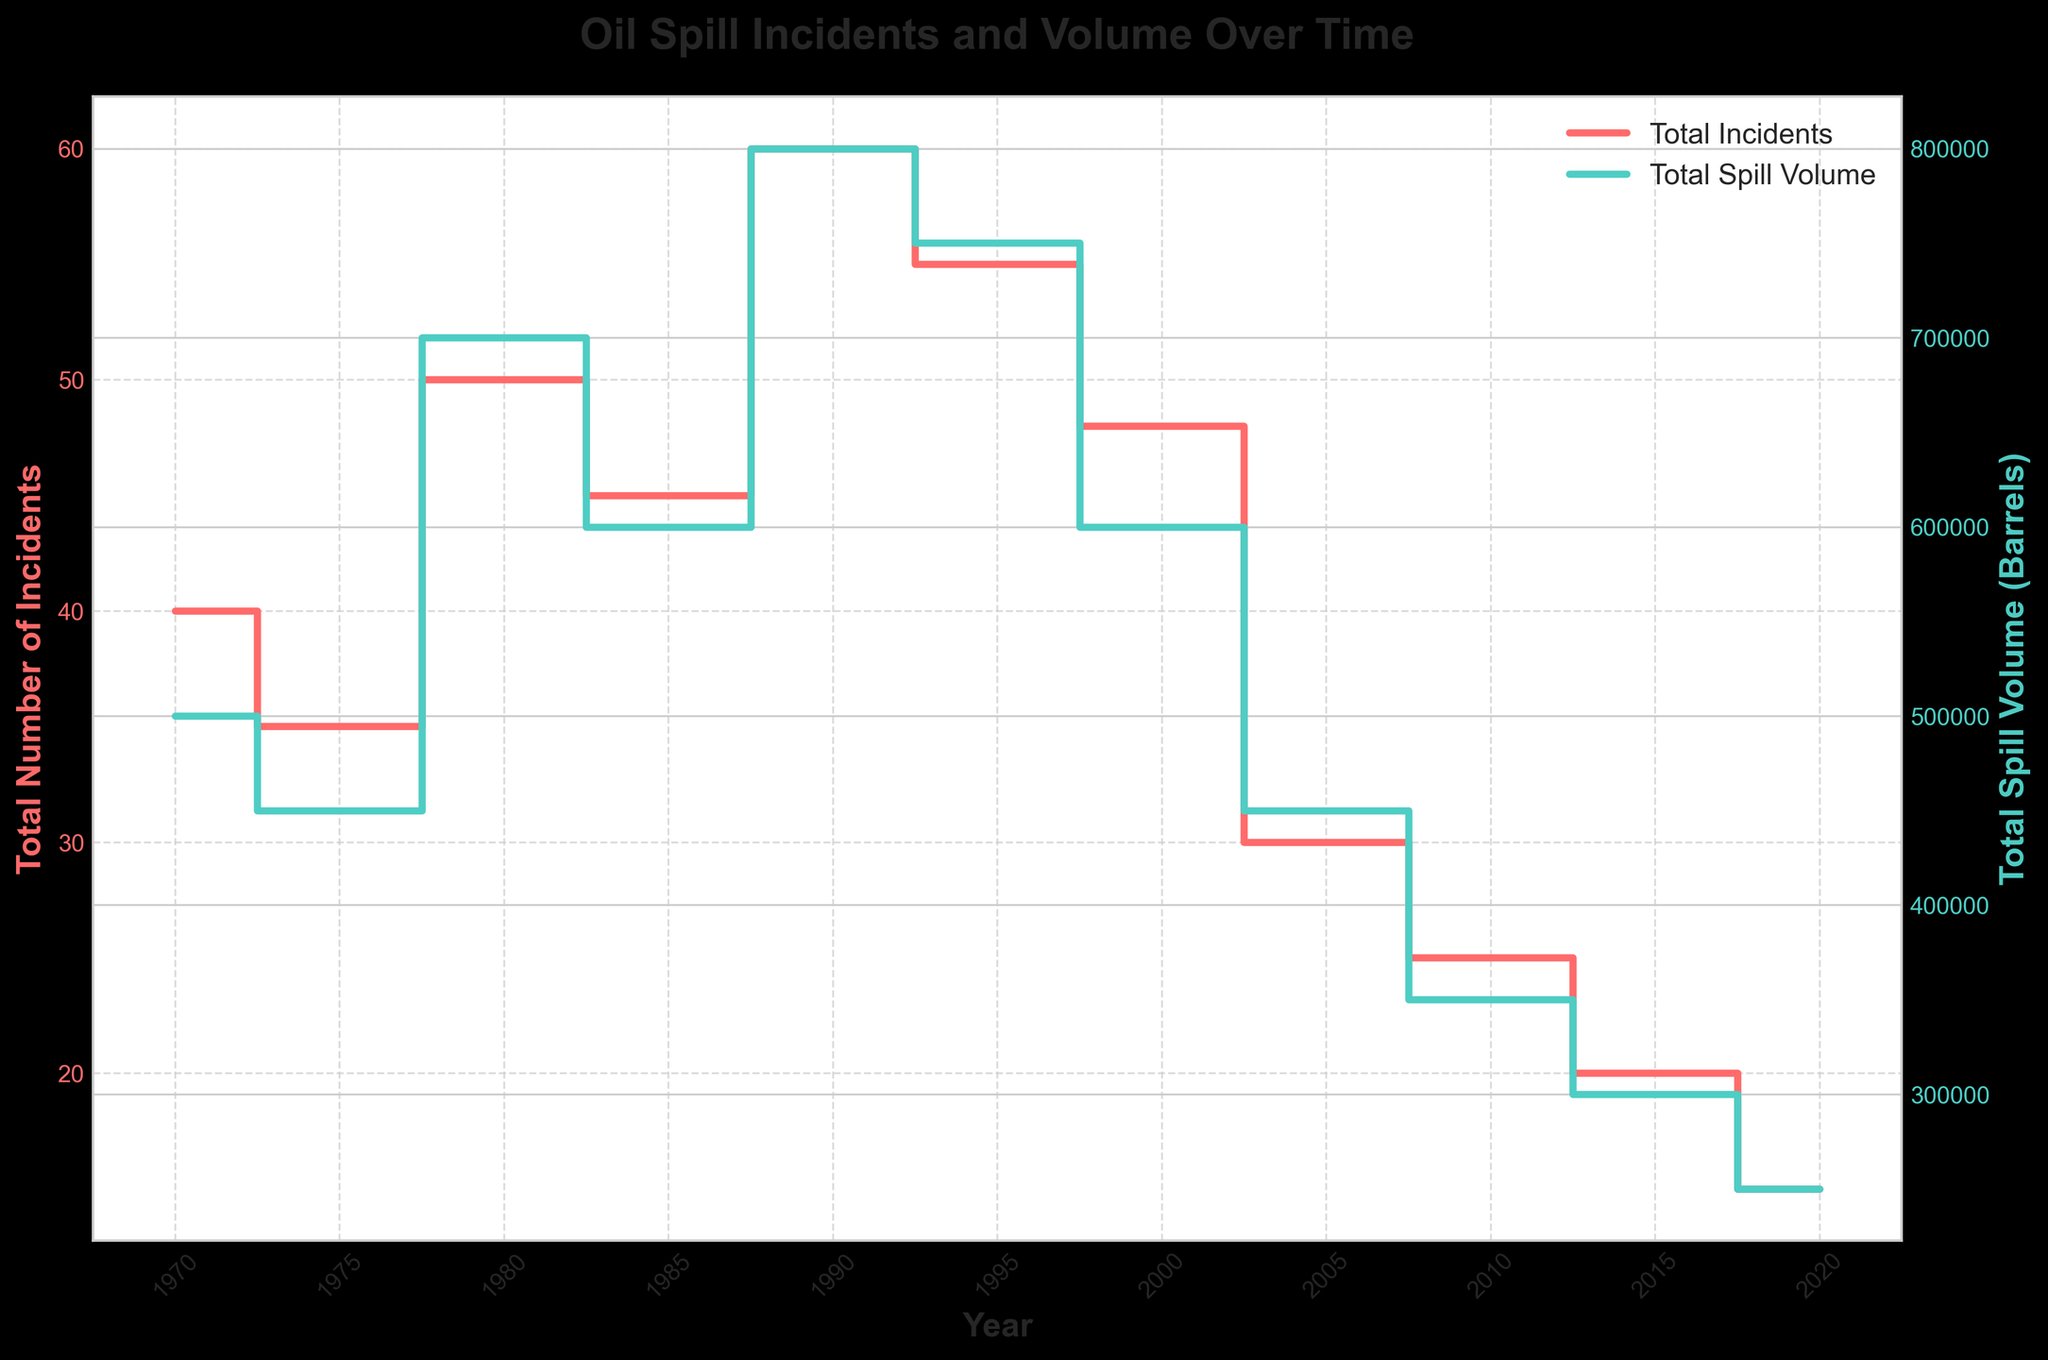What is the title of the plot? The title is located at the top of the figure. It describes what the plot represents.
Answer: Oil Spill Incidents and Volume Over Time What's the total number of incidents in 1985? Locate the year 1985 on the x-axis and read the corresponding value on the left y-axis labeled "Total Number of Incidents."
Answer: 45 What colors represent the Total Number of Incidents and Total Spill Volume? Identify the colored lines in the plot and match them with the labels in the legend.
Answer: Total Number of Incidents is red, Total Spill Volume is green When did the total spill volume peak? Look at the green step line for the highest value and find the corresponding year on the x-axis.
Answer: 1990 How does the average spill volume per incident in 1980 compare to 2020? To compare, note that in 1980: 700,000 barrels / 50 incidents = 14,000 barrels per incident; in 2020: 250,000 barrels / 15 incidents = 16,667 barrels per incident.
Answer: 1980: 14,000 barrels, 2020: 16,667 barrels In which year was the total number of incidents the lowest? Look for the minimum value on the red step line and the corresponding year on the x-axis.
Answer: 2020 How many total spill volume incidents were recorded in 1995 compared to 2005? Locate the years 1995 and 2005 on the x-axis and compare the corresponding green step line values to see the difference.
Answer: 1995: 750,000 barrels, 2005: 450,000 barrels What is the trend in the total number of incidents over the decades? Observe the overall direction of the red step line across the years, noting increases or decreases.
Answer: Decreasing trend What is the increase in Environmental Cleanup Success Rate from 1970 to 2020? The difference between the success rates of 2020 (80%) and 1970 (30%) can be calculated by subtracting the latter from the former.
Answer: 50% Which has decreased more significantly over the years, the number of incidents or the total spill volume? Compare the slopes of the red (total number of incidents) and green (total spill volume) step lines from 1970 to 2020. Calculate the percentage decrease for both metrics. Total number of incidents decreased from 40 to 15 (62.5%), and total spill volume from 500,000 barrels to 250,000 barrels (50%).
Answer: Number of incidents 